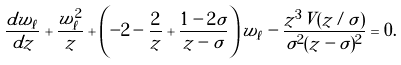Convert formula to latex. <formula><loc_0><loc_0><loc_500><loc_500>\frac { d w _ { \ell } } { d z } + \frac { w ^ { 2 } _ { \ell } } { z } + \left ( - 2 - \frac { 2 } { z } + \frac { 1 - 2 \sigma } { z - \sigma } \right ) w _ { \ell } - \frac { z ^ { 3 } V ( z / \sigma ) } { \sigma ^ { 2 } ( z - \sigma ) ^ { 2 } } = 0 .</formula> 